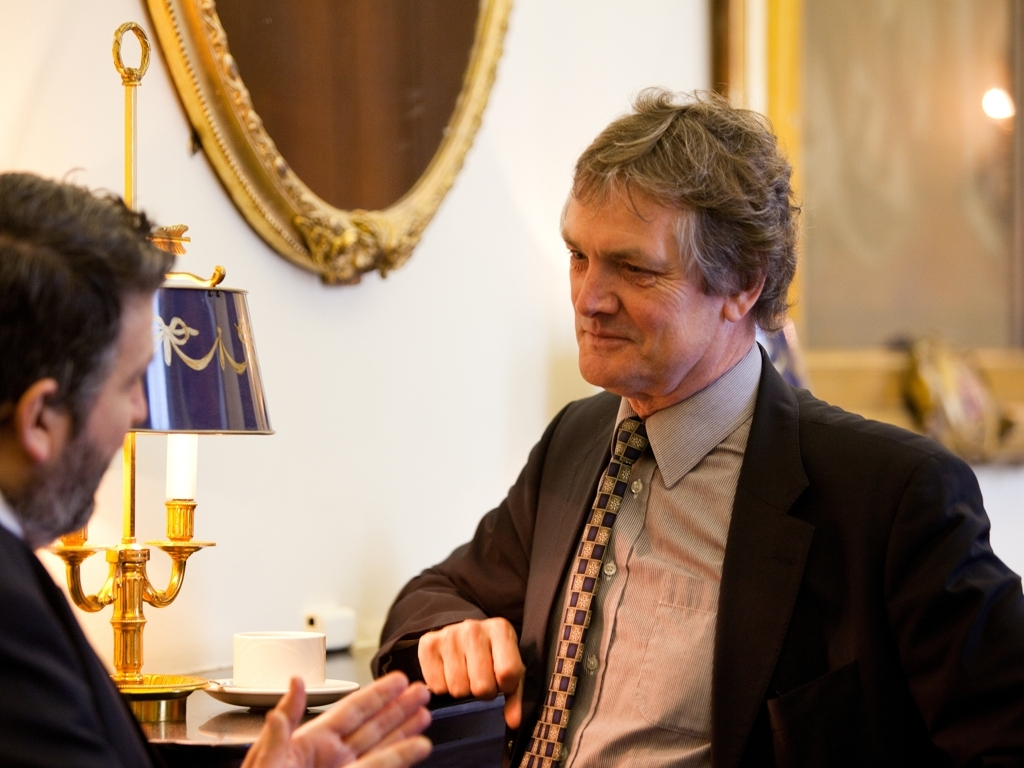How are the colors in the image?
A. Monochromatic
B. Faded
C. Vivid The colors in the image are quite vivid. There is a strong contrast between the rich golden tones of the lamp and the darker, muted colors in the rest of the setting. The gentleman's attire and the furnishings convey a sense of warmth and depth, which is characteristic of a vivid color palette. 